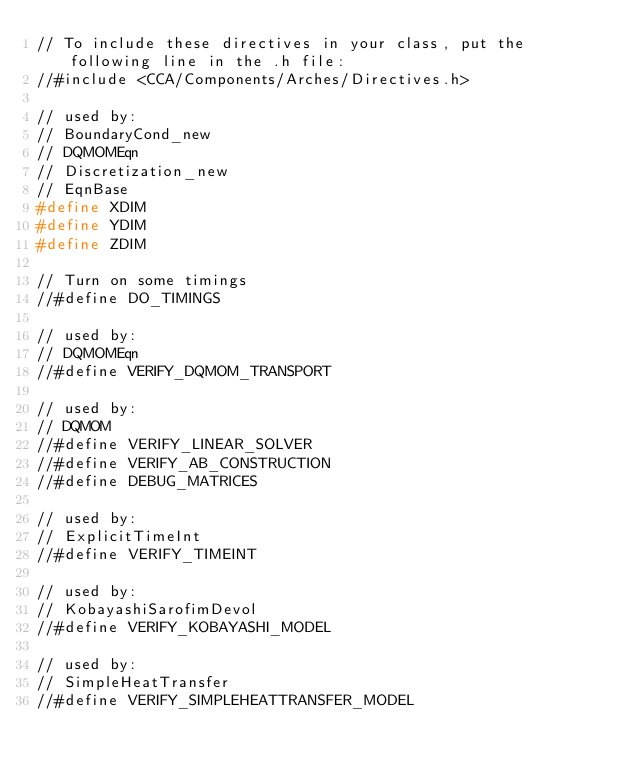Convert code to text. <code><loc_0><loc_0><loc_500><loc_500><_C_>// To include these directives in your class, put the following line in the .h file:
//#include <CCA/Components/Arches/Directives.h>

// used by:
// BoundaryCond_new
// DQMOMEqn
// Discretization_new
// EqnBase
#define XDIM
#define YDIM
#define ZDIM

// Turn on some timings
//#define DO_TIMINGS

// used by:
// DQMOMEqn
//#define VERIFY_DQMOM_TRANSPORT

// used by:
// DQMOM
//#define VERIFY_LINEAR_SOLVER
//#define VERIFY_AB_CONSTRUCTION
//#define DEBUG_MATRICES

// used by:
// ExplicitTimeInt
//#define VERIFY_TIMEINT

// used by:
// KobayashiSarofimDevol
//#define VERIFY_KOBAYASHI_MODEL

// used by:
// SimpleHeatTransfer
//#define VERIFY_SIMPLEHEATTRANSFER_MODEL
</code> 